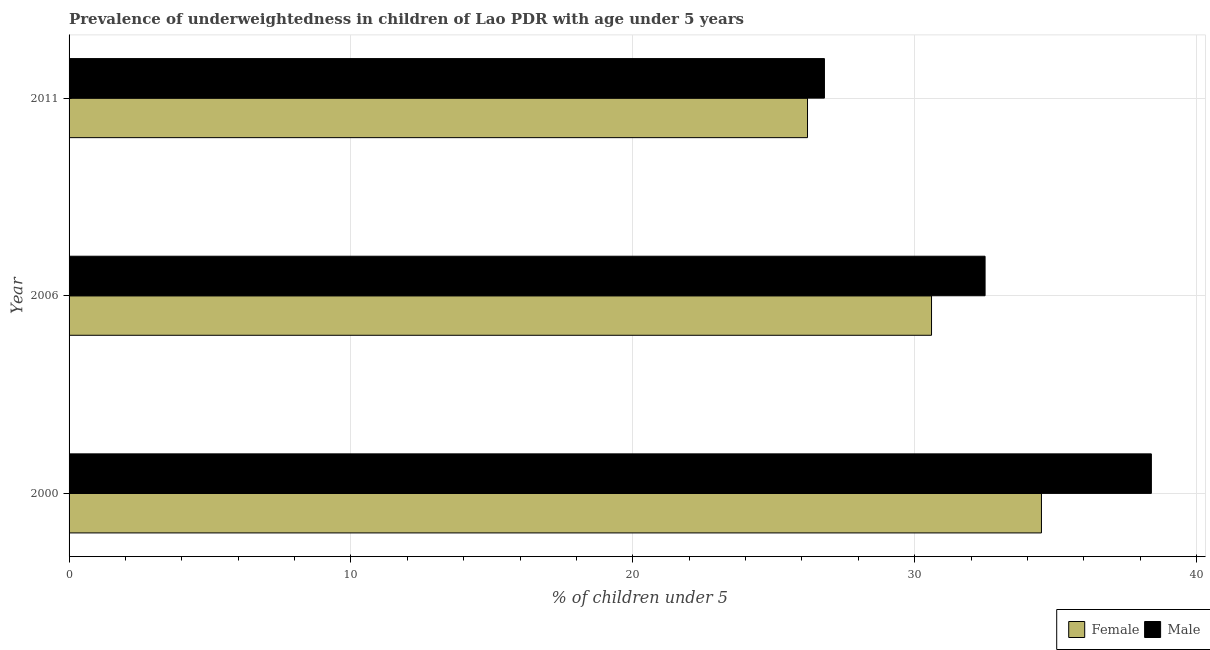How many bars are there on the 3rd tick from the bottom?
Offer a very short reply. 2. In how many cases, is the number of bars for a given year not equal to the number of legend labels?
Give a very brief answer. 0. What is the percentage of underweighted female children in 2006?
Offer a very short reply. 30.6. Across all years, what is the maximum percentage of underweighted male children?
Provide a short and direct response. 38.4. Across all years, what is the minimum percentage of underweighted female children?
Keep it short and to the point. 26.2. In which year was the percentage of underweighted male children maximum?
Provide a succinct answer. 2000. What is the total percentage of underweighted female children in the graph?
Provide a succinct answer. 91.3. What is the difference between the percentage of underweighted female children in 2006 and the percentage of underweighted male children in 2011?
Keep it short and to the point. 3.8. What is the average percentage of underweighted female children per year?
Keep it short and to the point. 30.43. In the year 2006, what is the difference between the percentage of underweighted female children and percentage of underweighted male children?
Keep it short and to the point. -1.9. In how many years, is the percentage of underweighted female children greater than 12 %?
Keep it short and to the point. 3. What is the ratio of the percentage of underweighted male children in 2000 to that in 2006?
Provide a short and direct response. 1.18. What is the difference between the highest and the lowest percentage of underweighted female children?
Your answer should be very brief. 8.3. In how many years, is the percentage of underweighted female children greater than the average percentage of underweighted female children taken over all years?
Provide a succinct answer. 2. Is the sum of the percentage of underweighted female children in 2000 and 2006 greater than the maximum percentage of underweighted male children across all years?
Your answer should be very brief. Yes. What does the 1st bar from the top in 2006 represents?
Make the answer very short. Male. Are all the bars in the graph horizontal?
Offer a terse response. Yes. What is the difference between two consecutive major ticks on the X-axis?
Your answer should be very brief. 10. Are the values on the major ticks of X-axis written in scientific E-notation?
Provide a succinct answer. No. Does the graph contain any zero values?
Give a very brief answer. No. How are the legend labels stacked?
Give a very brief answer. Horizontal. What is the title of the graph?
Keep it short and to the point. Prevalence of underweightedness in children of Lao PDR with age under 5 years. What is the label or title of the X-axis?
Your answer should be compact.  % of children under 5. What is the  % of children under 5 of Female in 2000?
Offer a very short reply. 34.5. What is the  % of children under 5 of Male in 2000?
Your answer should be very brief. 38.4. What is the  % of children under 5 of Female in 2006?
Provide a short and direct response. 30.6. What is the  % of children under 5 in Male in 2006?
Your answer should be very brief. 32.5. What is the  % of children under 5 of Female in 2011?
Keep it short and to the point. 26.2. What is the  % of children under 5 in Male in 2011?
Make the answer very short. 26.8. Across all years, what is the maximum  % of children under 5 in Female?
Make the answer very short. 34.5. Across all years, what is the maximum  % of children under 5 of Male?
Provide a short and direct response. 38.4. Across all years, what is the minimum  % of children under 5 of Female?
Keep it short and to the point. 26.2. Across all years, what is the minimum  % of children under 5 in Male?
Offer a terse response. 26.8. What is the total  % of children under 5 of Female in the graph?
Keep it short and to the point. 91.3. What is the total  % of children under 5 of Male in the graph?
Your answer should be very brief. 97.7. What is the difference between the  % of children under 5 of Female in 2000 and that in 2006?
Provide a succinct answer. 3.9. What is the difference between the  % of children under 5 in Male in 2000 and that in 2006?
Keep it short and to the point. 5.9. What is the difference between the  % of children under 5 in Female in 2000 and that in 2011?
Keep it short and to the point. 8.3. What is the difference between the  % of children under 5 in Male in 2000 and that in 2011?
Your answer should be compact. 11.6. What is the difference between the  % of children under 5 of Female in 2006 and that in 2011?
Your answer should be compact. 4.4. What is the difference between the  % of children under 5 of Male in 2006 and that in 2011?
Provide a succinct answer. 5.7. What is the difference between the  % of children under 5 in Female in 2000 and the  % of children under 5 in Male in 2006?
Give a very brief answer. 2. What is the difference between the  % of children under 5 of Female in 2006 and the  % of children under 5 of Male in 2011?
Make the answer very short. 3.8. What is the average  % of children under 5 in Female per year?
Your answer should be compact. 30.43. What is the average  % of children under 5 in Male per year?
Provide a succinct answer. 32.57. In the year 2006, what is the difference between the  % of children under 5 in Female and  % of children under 5 in Male?
Your answer should be very brief. -1.9. In the year 2011, what is the difference between the  % of children under 5 in Female and  % of children under 5 in Male?
Ensure brevity in your answer.  -0.6. What is the ratio of the  % of children under 5 of Female in 2000 to that in 2006?
Keep it short and to the point. 1.13. What is the ratio of the  % of children under 5 in Male in 2000 to that in 2006?
Give a very brief answer. 1.18. What is the ratio of the  % of children under 5 in Female in 2000 to that in 2011?
Provide a short and direct response. 1.32. What is the ratio of the  % of children under 5 of Male in 2000 to that in 2011?
Your response must be concise. 1.43. What is the ratio of the  % of children under 5 of Female in 2006 to that in 2011?
Provide a succinct answer. 1.17. What is the ratio of the  % of children under 5 in Male in 2006 to that in 2011?
Your response must be concise. 1.21. What is the difference between the highest and the lowest  % of children under 5 in Female?
Your answer should be very brief. 8.3. 